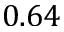Convert formula to latex. <formula><loc_0><loc_0><loc_500><loc_500>0 . 6 4</formula> 